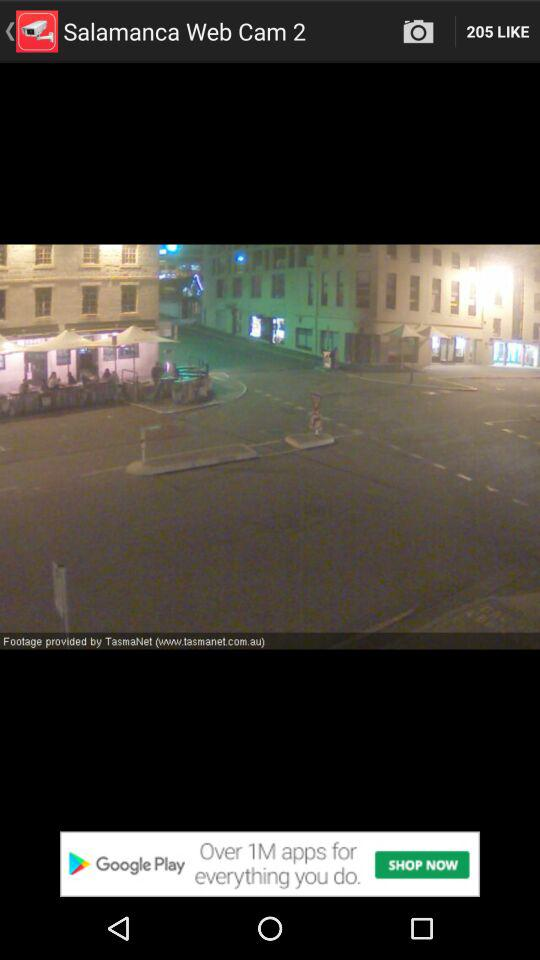What is the application name? The application name is "Salamanca Web Cam 2". 